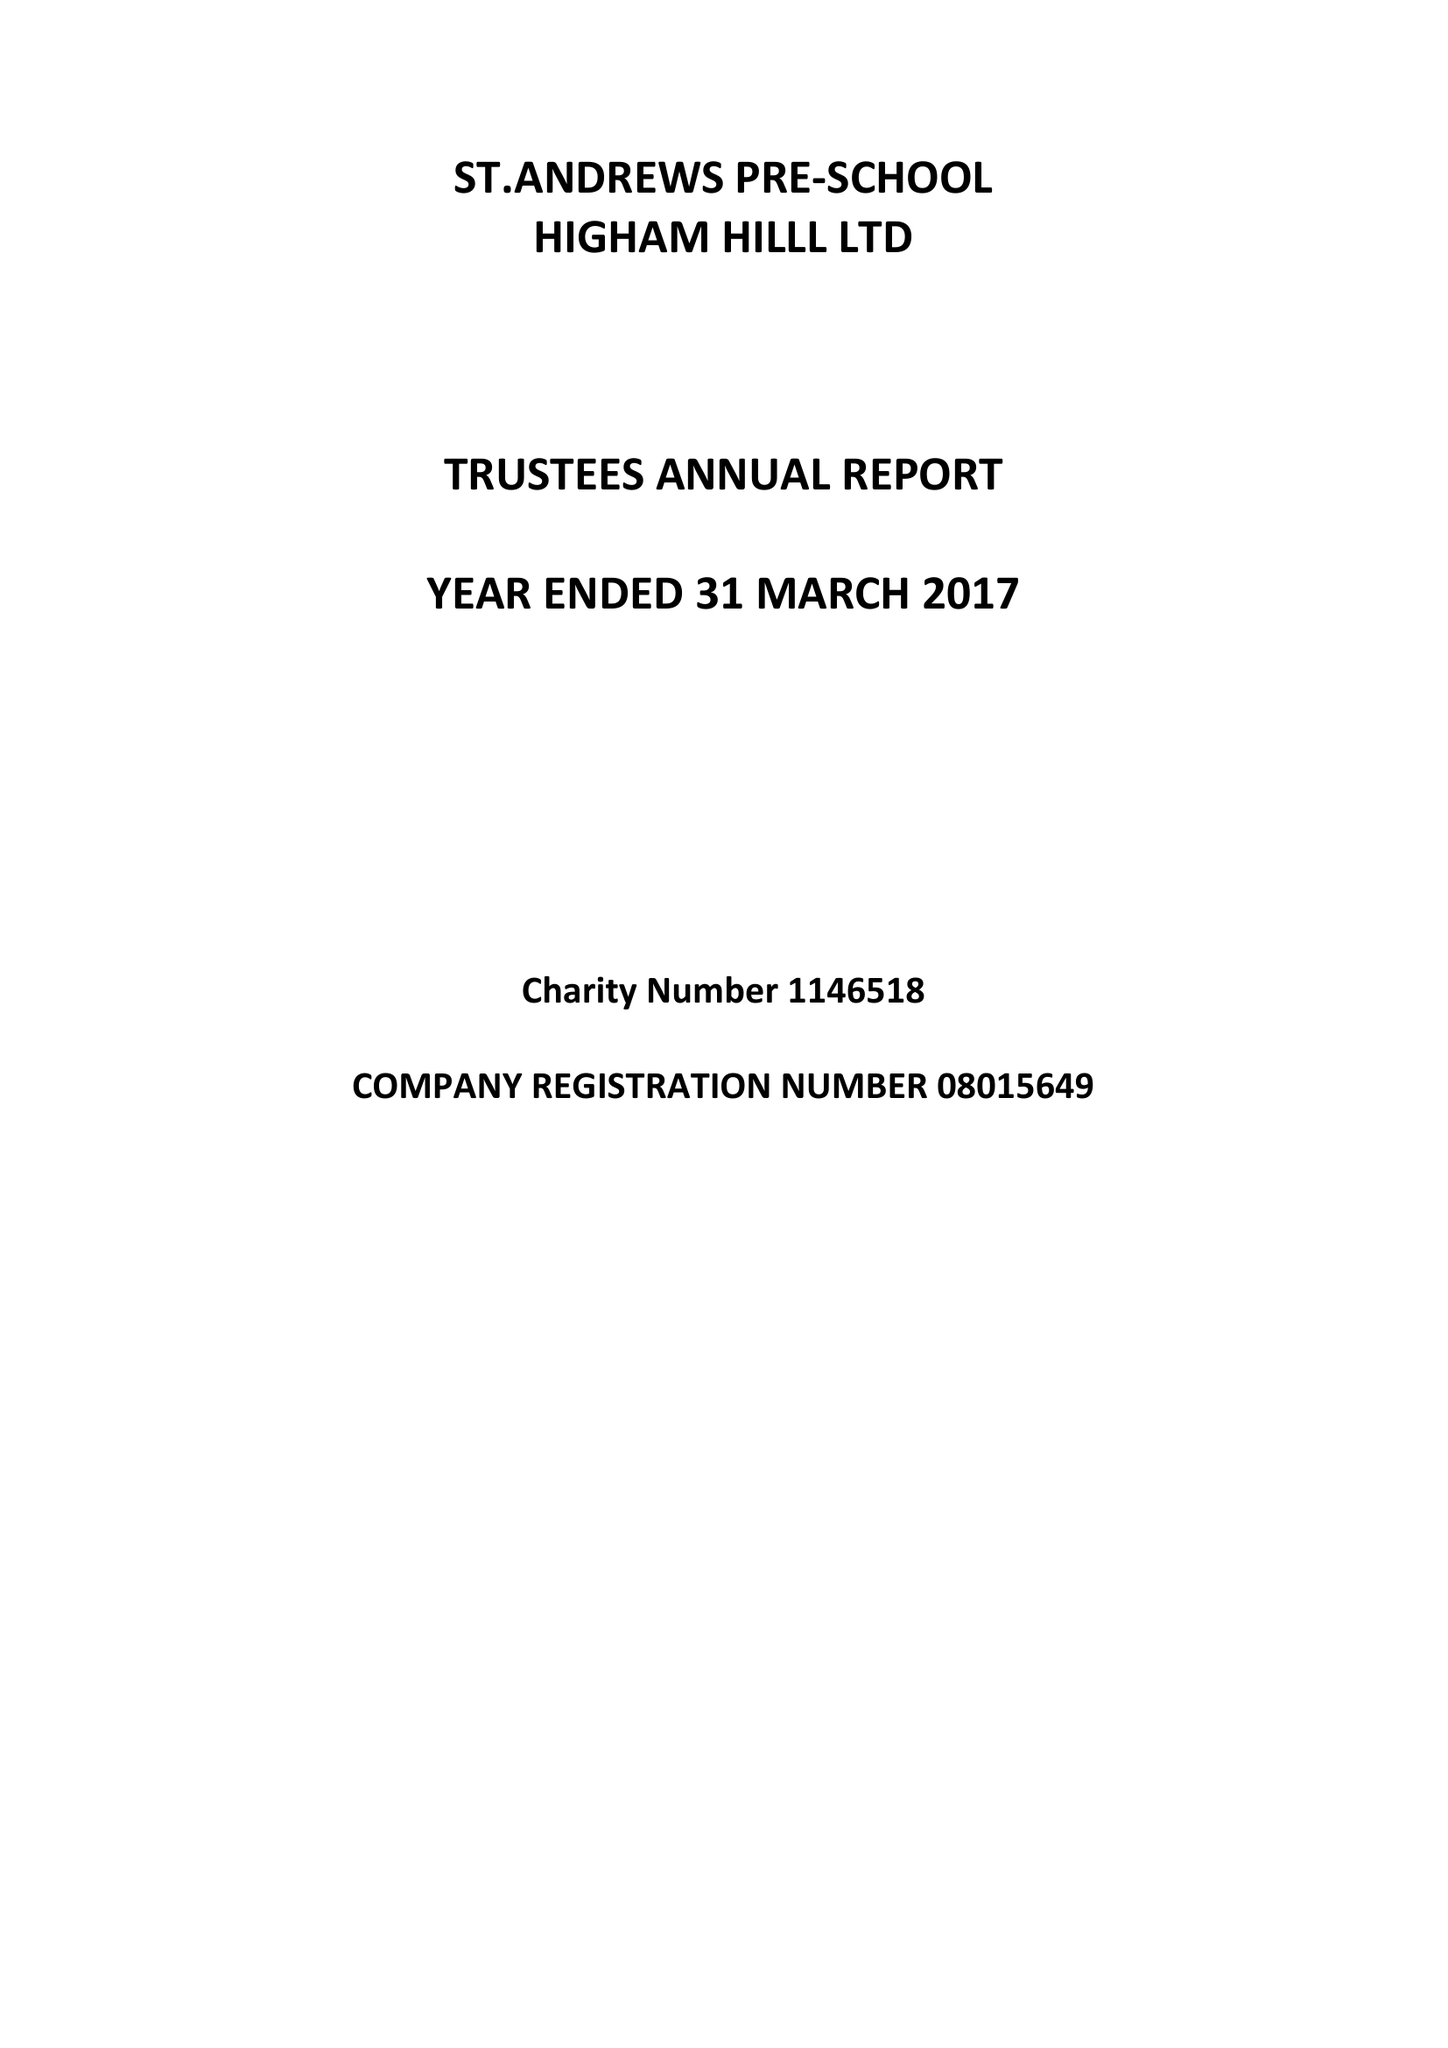What is the value for the income_annually_in_british_pounds?
Answer the question using a single word or phrase. 92293.00 